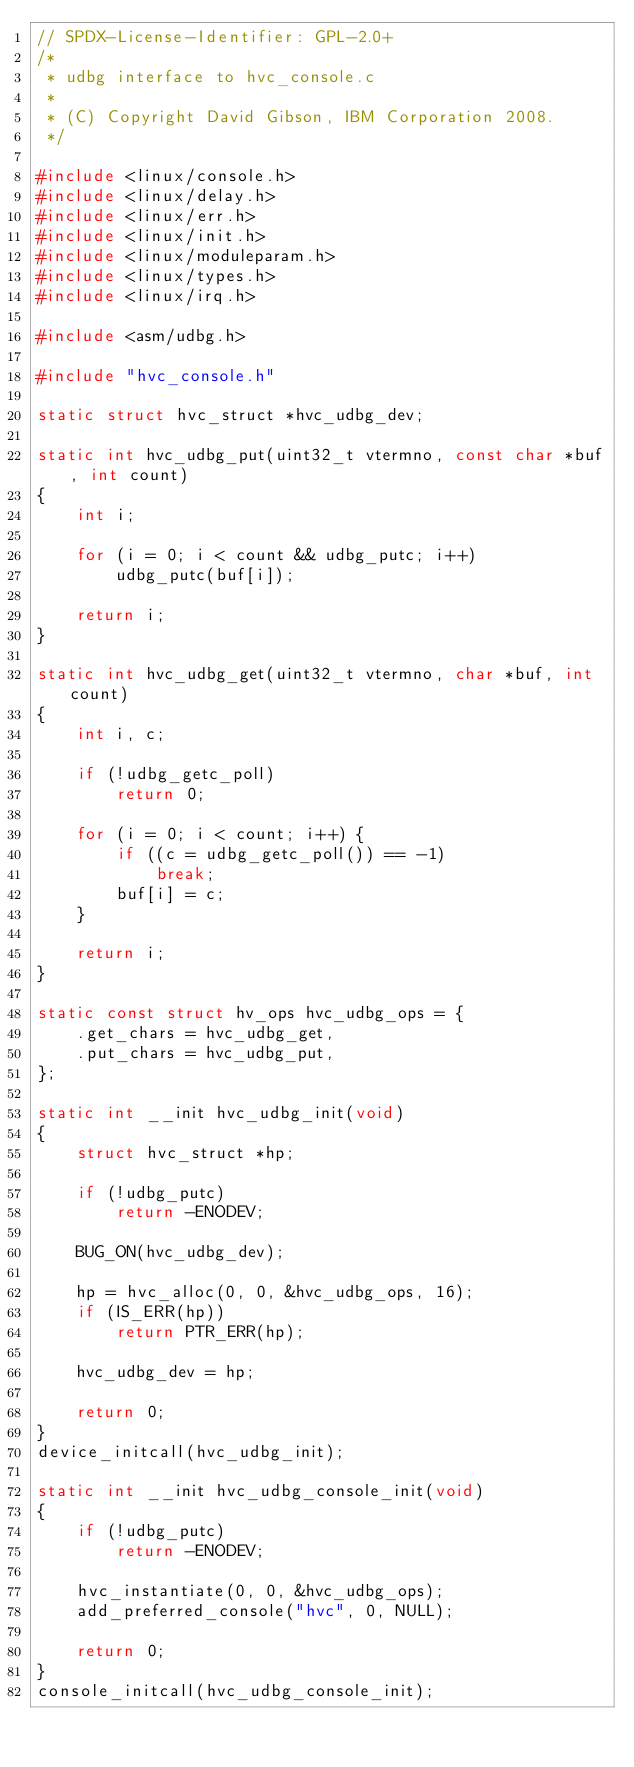<code> <loc_0><loc_0><loc_500><loc_500><_C_>// SPDX-License-Identifier: GPL-2.0+
/*
 * udbg interface to hvc_console.c
 *
 * (C) Copyright David Gibson, IBM Corporation 2008.
 */

#include <linux/console.h>
#include <linux/delay.h>
#include <linux/err.h>
#include <linux/init.h>
#include <linux/moduleparam.h>
#include <linux/types.h>
#include <linux/irq.h>

#include <asm/udbg.h>

#include "hvc_console.h"

static struct hvc_struct *hvc_udbg_dev;

static int hvc_udbg_put(uint32_t vtermno, const char *buf, int count)
{
	int i;

	for (i = 0; i < count && udbg_putc; i++)
		udbg_putc(buf[i]);

	return i;
}

static int hvc_udbg_get(uint32_t vtermno, char *buf, int count)
{
	int i, c;

	if (!udbg_getc_poll)
		return 0;

	for (i = 0; i < count; i++) {
		if ((c = udbg_getc_poll()) == -1)
			break;
		buf[i] = c;
	}

	return i;
}

static const struct hv_ops hvc_udbg_ops = {
	.get_chars = hvc_udbg_get,
	.put_chars = hvc_udbg_put,
};

static int __init hvc_udbg_init(void)
{
	struct hvc_struct *hp;

	if (!udbg_putc)
		return -ENODEV;

	BUG_ON(hvc_udbg_dev);

	hp = hvc_alloc(0, 0, &hvc_udbg_ops, 16);
	if (IS_ERR(hp))
		return PTR_ERR(hp);

	hvc_udbg_dev = hp;

	return 0;
}
device_initcall(hvc_udbg_init);

static int __init hvc_udbg_console_init(void)
{
	if (!udbg_putc)
		return -ENODEV;

	hvc_instantiate(0, 0, &hvc_udbg_ops);
	add_preferred_console("hvc", 0, NULL);

	return 0;
}
console_initcall(hvc_udbg_console_init);
</code> 